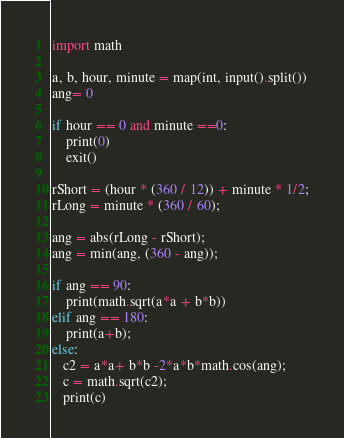<code> <loc_0><loc_0><loc_500><loc_500><_Python_>import math

a, b, hour, minute = map(int, input().split())
ang= 0

if hour == 0 and minute ==0:
    print(0)
    exit()

rShort = (hour * (360 / 12)) + minute * 1/2;
rLong = minute * (360 / 60);

ang = abs(rLong - rShort);
ang = min(ang, (360 - ang));

if ang == 90:
    print(math.sqrt(a*a + b*b))
elif ang == 180:
    print(a+b);
else:
   c2 = a*a+ b*b -2*a*b*math.cos(ang);
   c = math.sqrt(c2);
   print(c)</code> 